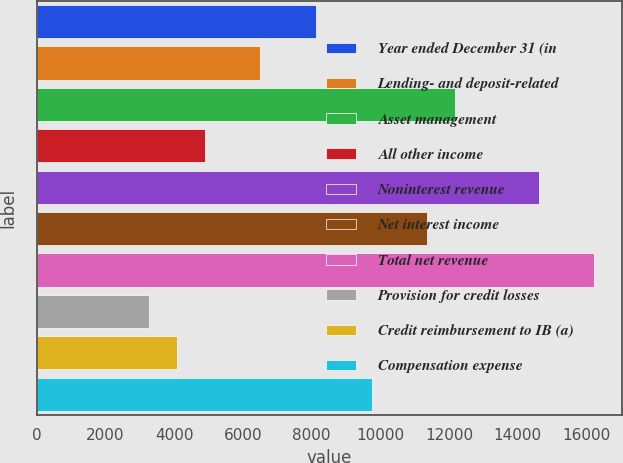<chart> <loc_0><loc_0><loc_500><loc_500><bar_chart><fcel>Year ended December 31 (in<fcel>Lending- and deposit-related<fcel>Asset management<fcel>All other income<fcel>Noninterest revenue<fcel>Net interest income<fcel>Total net revenue<fcel>Provision for credit losses<fcel>Credit reimbursement to IB (a)<fcel>Compensation expense<nl><fcel>8134<fcel>6513.8<fcel>12184.5<fcel>4893.6<fcel>14614.8<fcel>11374.4<fcel>16235<fcel>3273.4<fcel>4083.5<fcel>9754.2<nl></chart> 